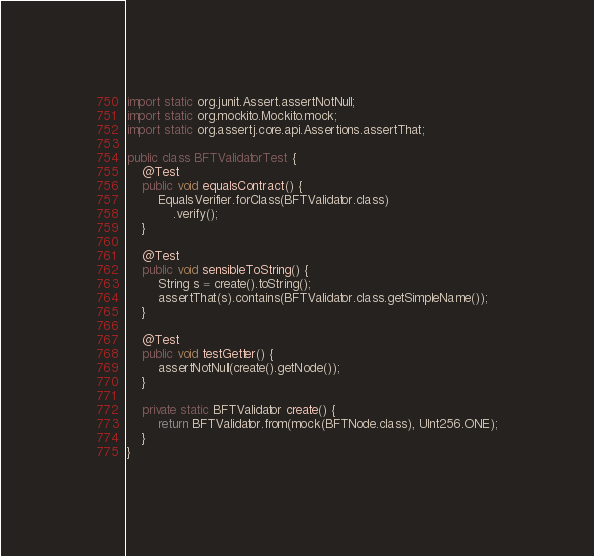<code> <loc_0><loc_0><loc_500><loc_500><_Java_>import static org.junit.Assert.assertNotNull;
import static org.mockito.Mockito.mock;
import static org.assertj.core.api.Assertions.assertThat;

public class BFTValidatorTest {
	@Test
	public void equalsContract() {
		EqualsVerifier.forClass(BFTValidator.class)
			.verify();
	}

	@Test
	public void sensibleToString() {
		String s = create().toString();
		assertThat(s).contains(BFTValidator.class.getSimpleName());
	}

	@Test
	public void testGetter() {
		assertNotNull(create().getNode());
	}

	private static BFTValidator create() {
		return BFTValidator.from(mock(BFTNode.class), UInt256.ONE);
	}
}
</code> 